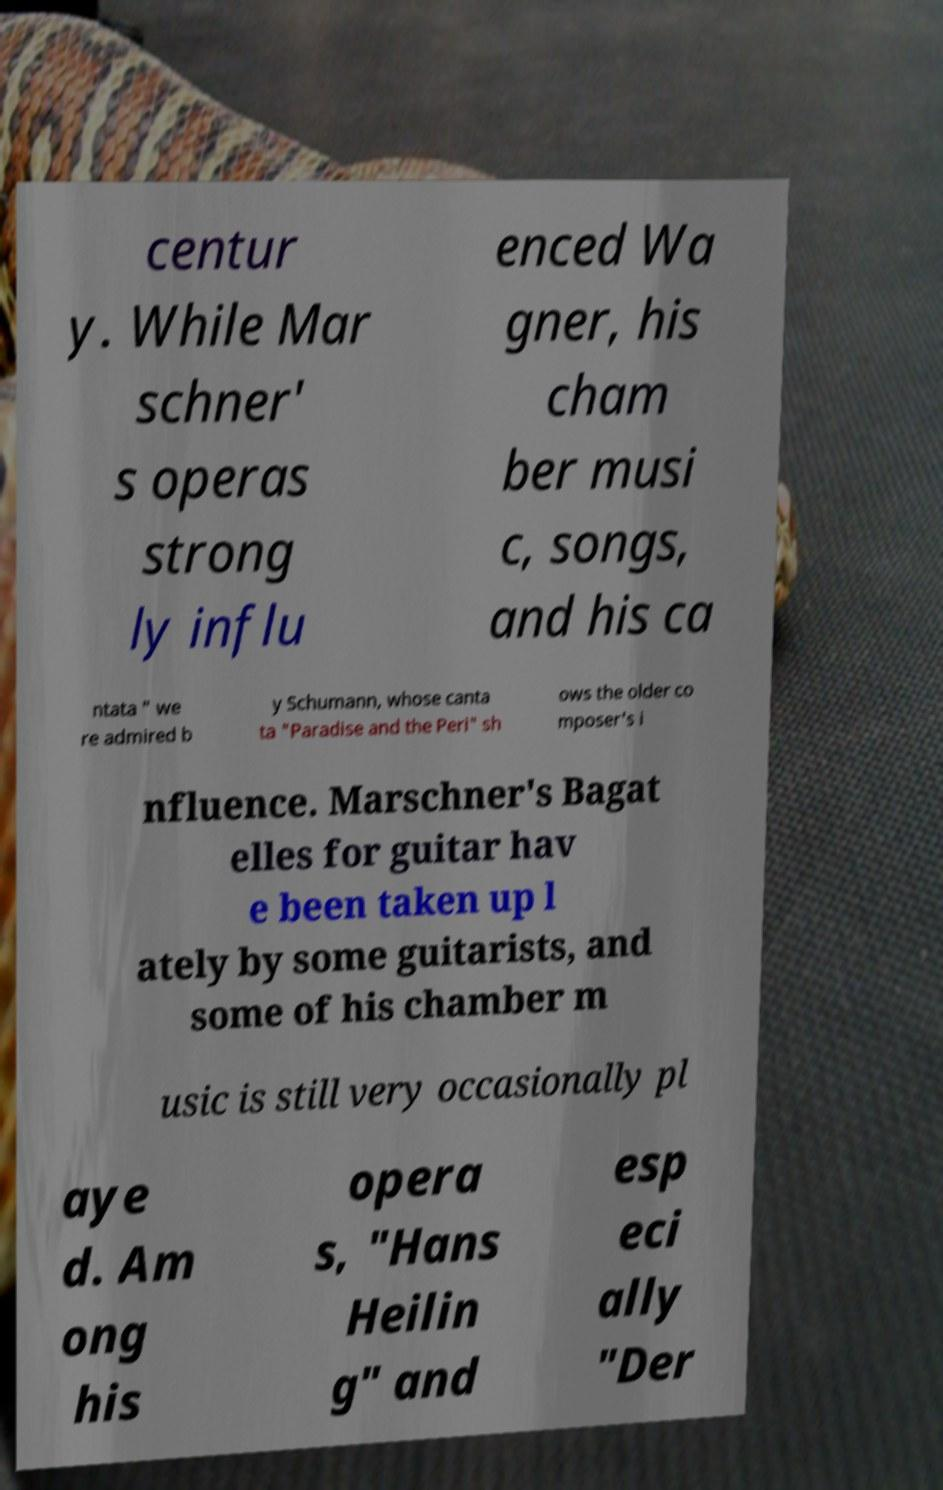Please identify and transcribe the text found in this image. centur y. While Mar schner' s operas strong ly influ enced Wa gner, his cham ber musi c, songs, and his ca ntata " we re admired b y Schumann, whose canta ta "Paradise and the Peri" sh ows the older co mposer's i nfluence. Marschner's Bagat elles for guitar hav e been taken up l ately by some guitarists, and some of his chamber m usic is still very occasionally pl aye d. Am ong his opera s, "Hans Heilin g" and esp eci ally "Der 